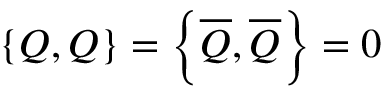Convert formula to latex. <formula><loc_0><loc_0><loc_500><loc_500>\left \{ Q , Q \right \} = \left \{ { \overline { Q } } , { \overline { Q } } \right \} = 0</formula> 